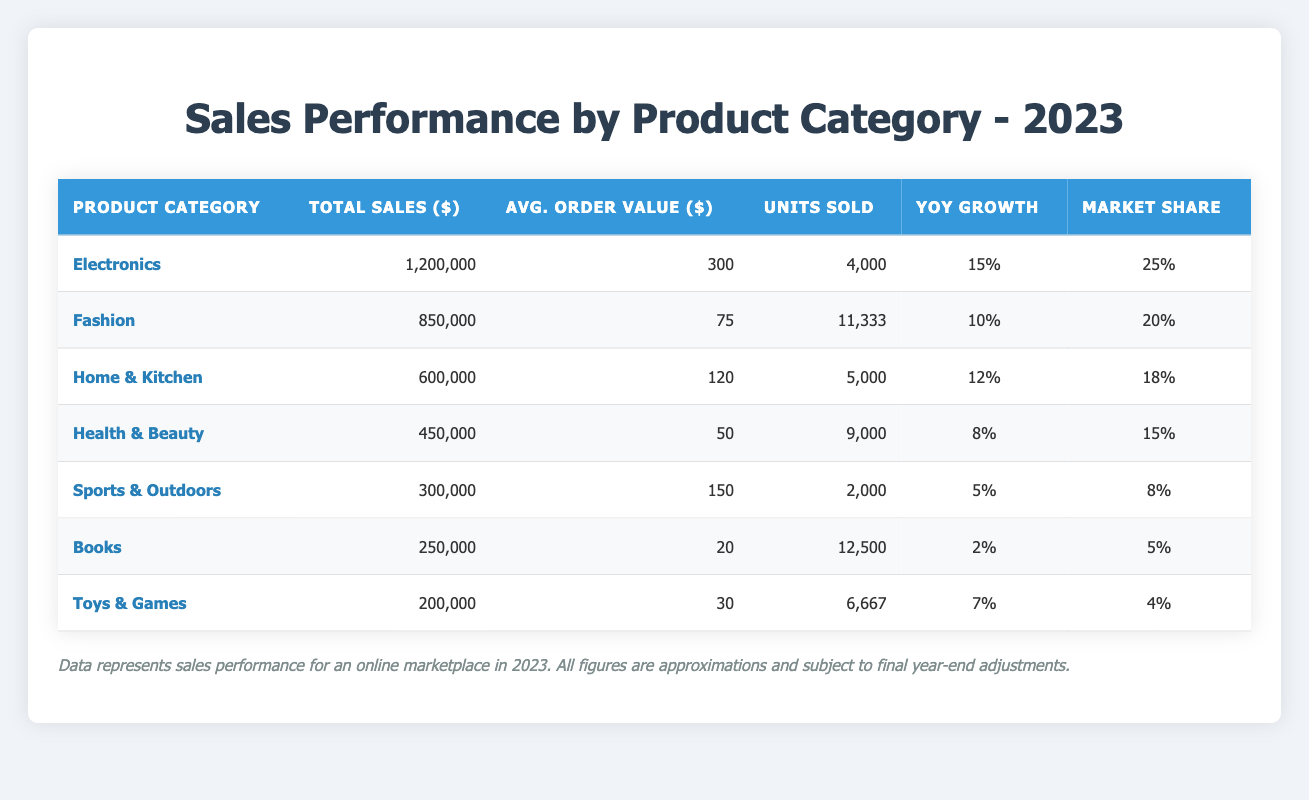What is the total sales for the Electronics category? The total sales for the Electronics category is directly provided in the table, which states that total sales amount to $1,200,000.
Answer: $1,200,000 Which product category has the highest average order value? The table lists the average order values of each category, and the Electronics category has an average order value of $300, which is higher than the other categories.
Answer: Electronics What is the market share percentage of the Fashion category? The table indicates that the Fashion category has a market share of 20%.
Answer: 20% Which product category experienced the lowest year-on-year growth? By reviewing the year-on-year growth percentages in the table, Books has the lowest growth at 2%.
Answer: Books How many units were sold for the Home & Kitchen category? The table shows that the number of units sold for the Home & Kitchen category is 5,000.
Answer: 5,000 What is the total sales for all product categories combined? To find the total sales, we add the total sales numbers from all categories: $1,200,000 + $850,000 + $600,000 + $450,000 + $300,000 + $250,000 + $200,000 = $3,850,000.
Answer: $3,850,000 Is the average order value for Health & Beauty greater than the average order value for Books? The average order value for Health & Beauty is $50 and for Books is $20. Since $50 is greater than $20, the statement is true.
Answer: Yes What is the difference in total sales between the Electronics and Fashion categories? The total sales for Electronics is $1,200,000 and for Fashion is $850,000, so their difference is $1,200,000 - $850,000 = $350,000.
Answer: $350,000 How many more units were sold in the Fashion category compared to the Sports & Outdoors category? Units sold for Fashion is 11,333, and for Sports & Outdoors, it is 2,000. The difference is 11,333 - 2,000 = 9,333 units.
Answer: 9,333 Which category has a higher market share: Health & Beauty or Sports & Outdoors? Health & Beauty has a market share of 15% and Sports & Outdoors has 8%. Compared to Sports & Outdoors, Health & Beauty has a higher market share.
Answer: Health & Beauty 